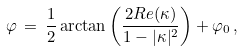<formula> <loc_0><loc_0><loc_500><loc_500>\varphi \, = \, \frac { 1 } { 2 } \arctan \left ( \frac { 2 R e ( \kappa ) } { 1 - | \kappa | ^ { 2 } } \right ) + \varphi _ { 0 } \, ,</formula> 